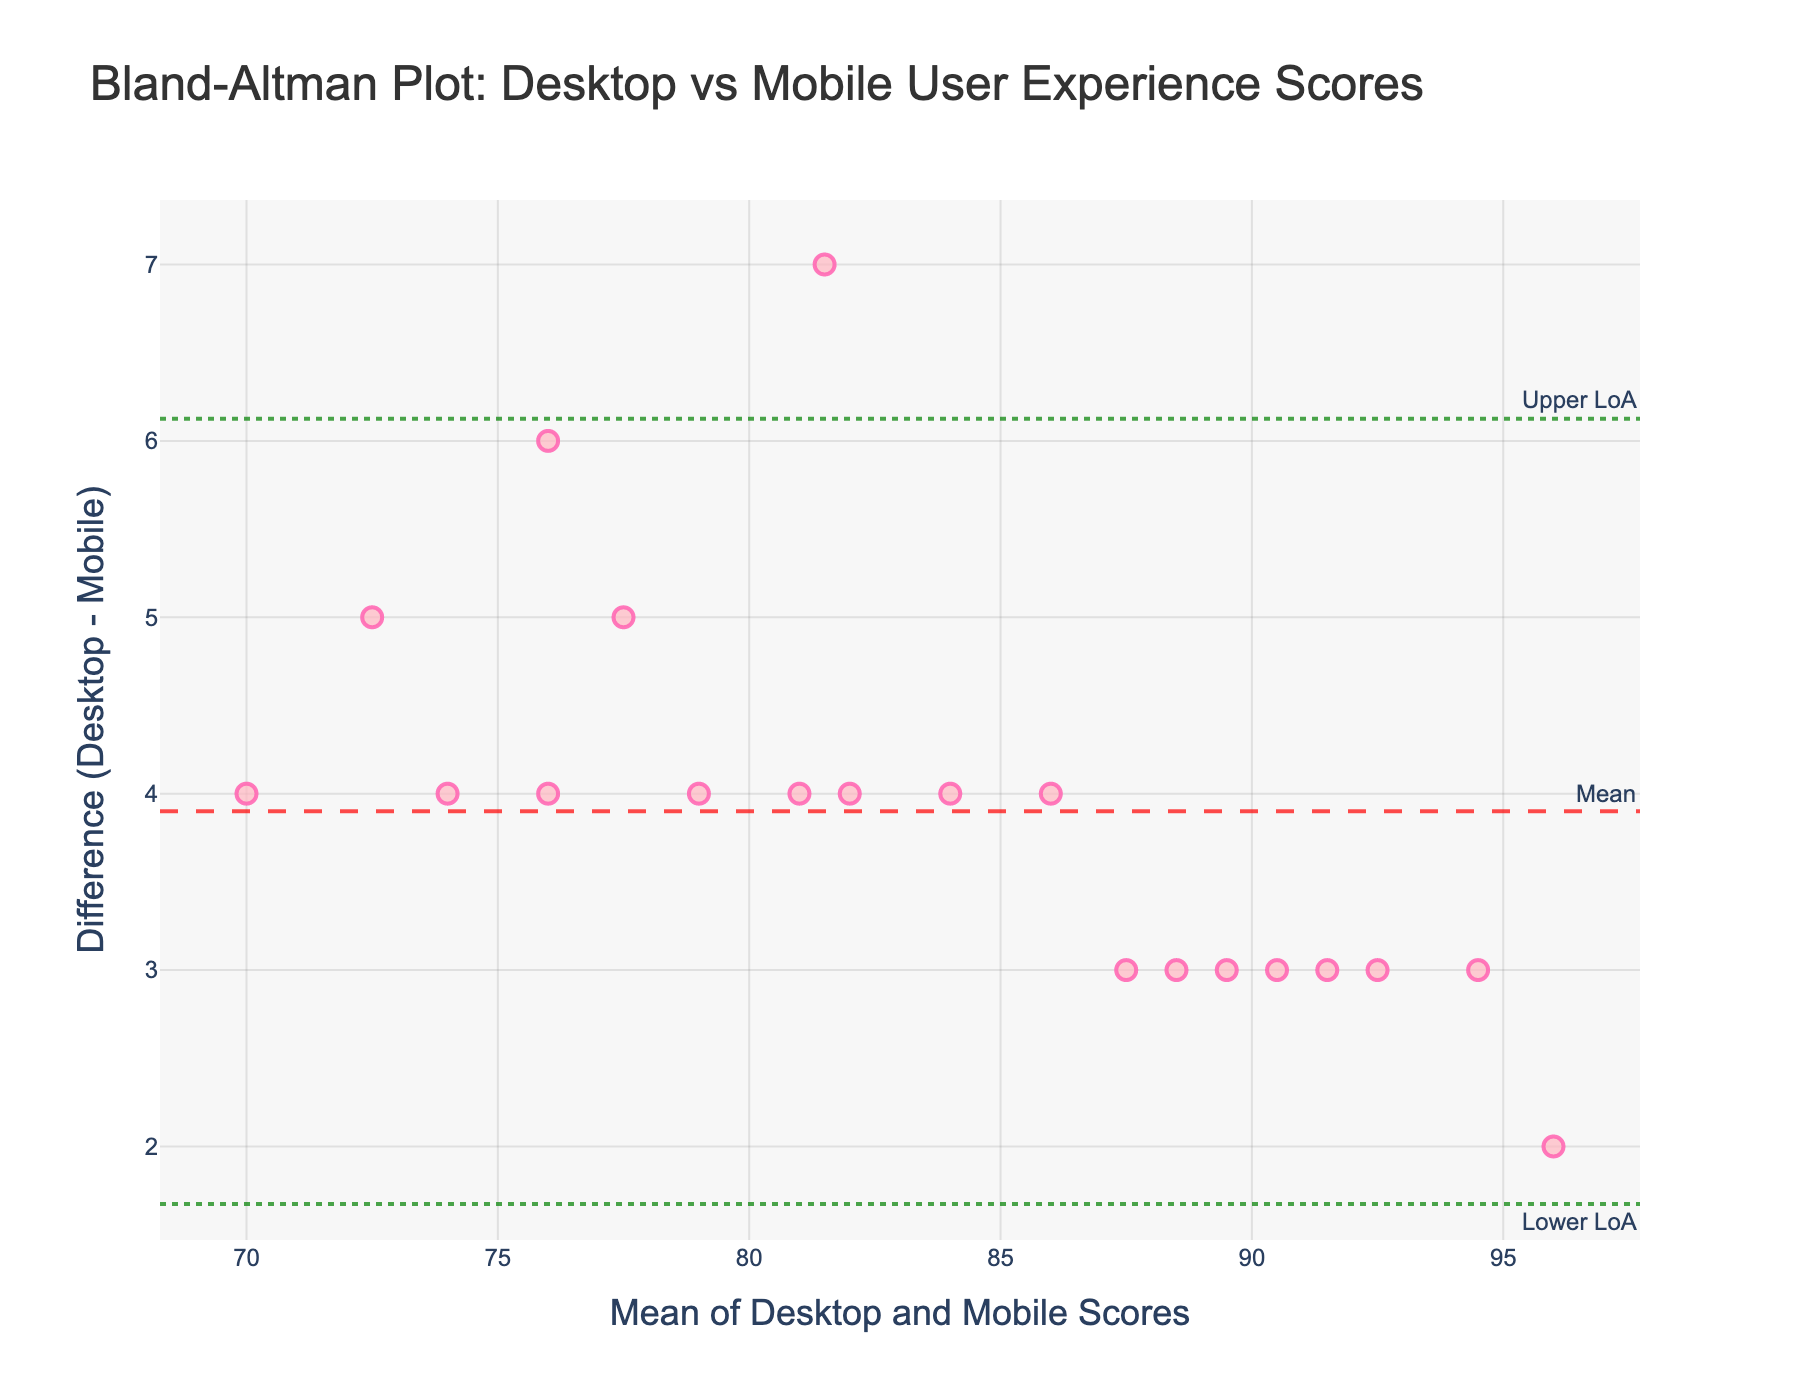What is the title of the plot? The title is usually placed at the top-center of the plot. The title in this case is clearly stated above the plot.
Answer: Bland-Altman Plot: Desktop vs Mobile User Experience Scores What do the points on the plot represent? The points represent individual data points where the x-axis is the mean value of the Desktop and Mobile scores, and the y-axis is the difference between the Desktop and Mobile scores.
Answer: Data points: mean vs difference How many data points are scattered in the plot? To determine the number of data points, you look at the number of distinct markers on the plot. Each data point represents one pair of Desktop and Mobile user experience scores.
Answer: 20 What is the mean difference between Desktop and Mobile scores? You can find this indicated by the dashed horizontal line labeled "Mean."
Answer: Mean difference is around 3.0 What are the upper and lower limits of agreement (LoA) in the plot? The upper limit of agreement is shown by the upper dotted line labeled "Upper LoA," and the lower limit of agreement is shown by the lower dotted line labeled "Lower LoA."
Answer: Upper LoA is around 5.4, Lower LoA is around 0.6 Where are most of the data points concentrated in terms of the x-axis (mean scores)? To determine concentration, observe the area with the highest density of points on the x-axis. Most of the points seem to cluster around the middle values of the mean scores.
Answer: Around a mean score of 85 Is there a pattern in the differences between Desktop and Mobile scores as the mean score increases? Looking for patterns would involve checking if there's any visible trend (e.g., increasing or decreasing differences) as you move along the x-axis from left to right.
Answer: No clear pattern What can you infer if a point lies above the mean difference line but within the limits of agreement? A point above the mean difference and within the LoA indicates that the Desktop score is higher than the Mobile score, but the difference is within the acceptable range.
Answer: Higher Desktop score, acceptable range What does it indicate if a point is outside the upper limit of agreement? A point outside the upper limit of agreement shows a significant disagreement where the Desktop score is much higher than the Mobile score.
Answer: Significant disagreement, higher Desktop score Is there any point exactly on the mean difference line? Checking this involves looking at the plot to see if any point lies precisely on the mean difference line. This would indicate the Desktop and Mobile scores differ by exactly the mean difference.
Answer: No 